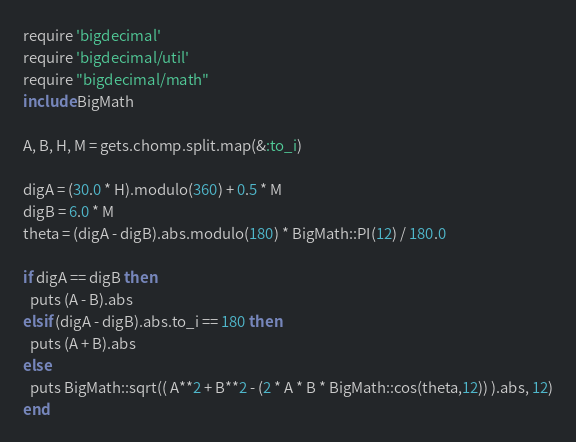<code> <loc_0><loc_0><loc_500><loc_500><_Ruby_>require 'bigdecimal'
require 'bigdecimal/util'
require "bigdecimal/math"
include BigMath

A, B, H, M = gets.chomp.split.map(&:to_i)

digA = (30.0 * H).modulo(360) + 0.5 * M
digB = 6.0 * M
theta = (digA - digB).abs.modulo(180) * BigMath::PI(12) / 180.0

if digA == digB then
  puts (A - B).abs
elsif (digA - digB).abs.to_i == 180 then
  puts (A + B).abs
else
  puts BigMath::sqrt(( A**2 + B**2 - (2 * A * B * BigMath::cos(theta,12)) ).abs, 12)
end</code> 